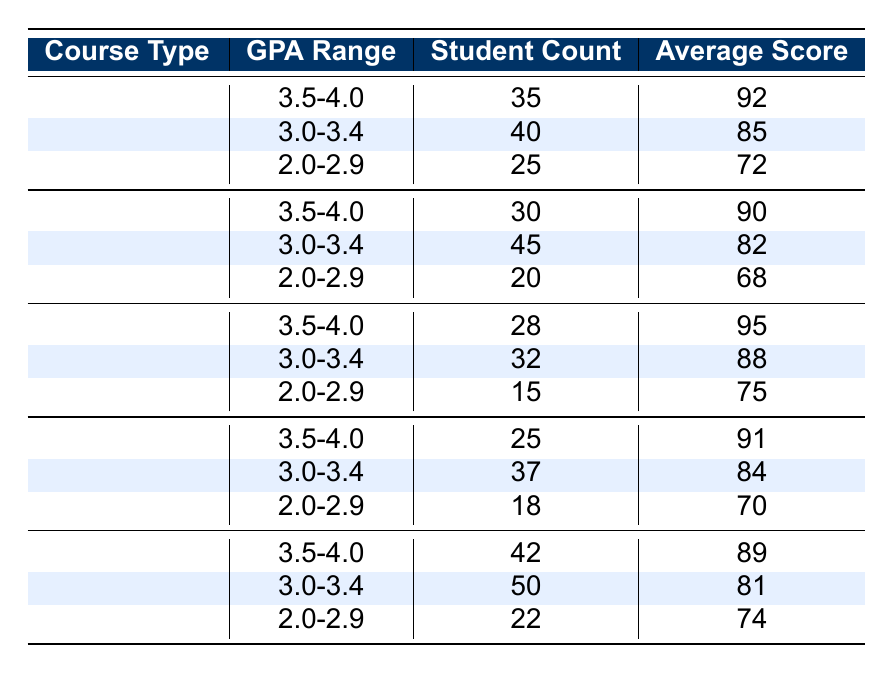What is the average score for students in the Humanities with a GPA range of 3.5-4.0? The average score in the Humanities for the GPA range of 3.5-4.0 is directly provided in the table. It is listed as 95.
Answer: 95 How many students took Mathematics courses with a GPA range of 2.0-2.9? The student count for the Mathematics course within the GPA range of 2.0-2.9 is directly mentioned in the table as 25.
Answer: 25 What is the total student count for Science courses across all GPA ranges? To find the total student count for Science, we add the student counts of all three GPA ranges: 30 (3.5-4.0) + 45 (3.0-3.4) + 20 (2.0-2.9) = 95.
Answer: 95 Is the average score for Business students with a GPA range of 3.0-3.4 greater than 80? The average score for Business students with a GPA range of 3.0-3.4 is 81, which is indeed greater than 80.
Answer: Yes In which course type did students in the GPA range of 2.0-2.9 have the highest average score? We compare the average scores for 2.0-2.9 across all course types: Mathematics (72), Science (68), Humanities (75), Engineering (70), and Business (74). The highest average is for Humanities at 75.
Answer: Humanities How many students in total are represented in the GPA range of 3.5-4.0 across all course types? We sum the student counts for the 3.5-4.0 GPA range across all course types: Mathematics (35), Science (30), Humanities (28), Engineering (25), and Business (42). The total is 35 + 30 + 28 + 25 + 42 = 160.
Answer: 160 What is the difference in average scores between students in Mathematics and Engineering with a GPA range of 3.0-3.4? The average score for Mathematics students in this range is 85, while for Engineering, it is 84. The difference is 85 - 84 = 1.
Answer: 1 Are there more students in the 3.0-3.4 GPA range for Humanities than for Science? The student count for Humanities in the 3.0-3.4 range is 32, and for Science, it is 45. Since 32 is less than 45, the answer is no.
Answer: No Which GPA range in Humanities has the least number of students? In Humanities, the 2.0-2.9 GPA range has the least student count, which is 15. This is less than the other two ranges (28 and 32).
Answer: 2.0-2.9 